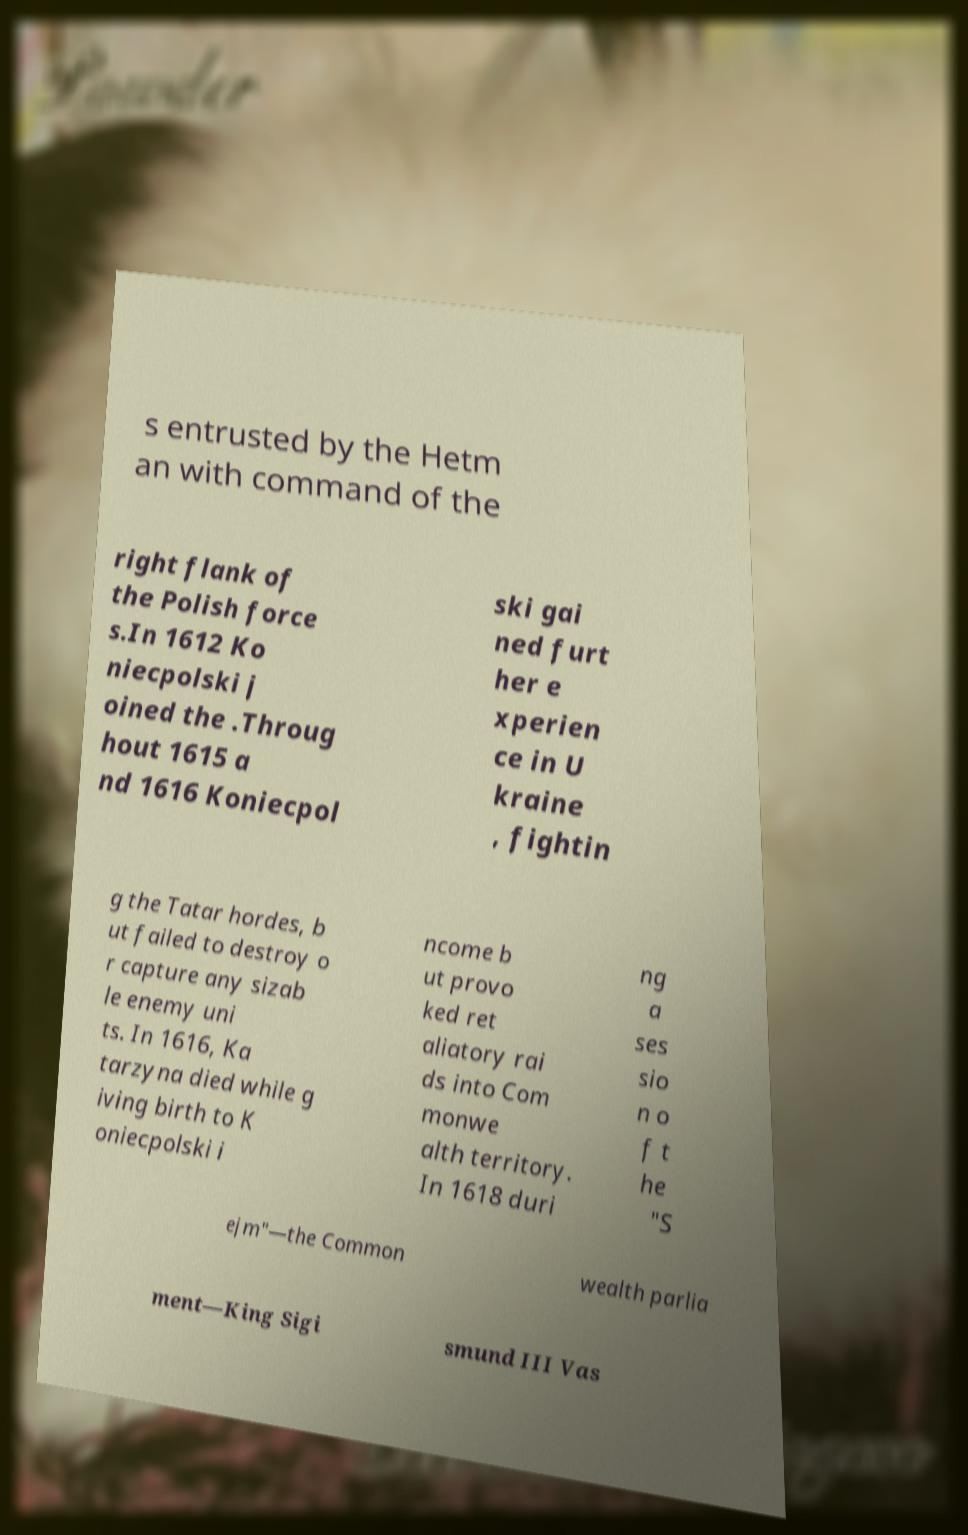Can you read and provide the text displayed in the image?This photo seems to have some interesting text. Can you extract and type it out for me? s entrusted by the Hetm an with command of the right flank of the Polish force s.In 1612 Ko niecpolski j oined the .Throug hout 1615 a nd 1616 Koniecpol ski gai ned furt her e xperien ce in U kraine , fightin g the Tatar hordes, b ut failed to destroy o r capture any sizab le enemy uni ts. In 1616, Ka tarzyna died while g iving birth to K oniecpolski i ncome b ut provo ked ret aliatory rai ds into Com monwe alth territory. In 1618 duri ng a ses sio n o f t he "S ejm"—the Common wealth parlia ment—King Sigi smund III Vas 